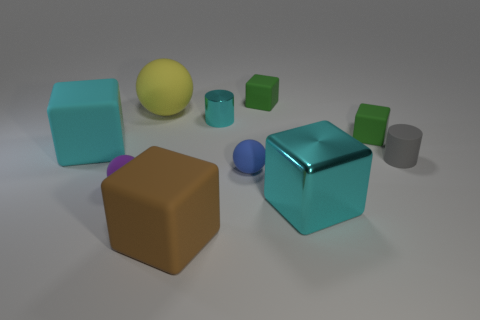How is the lighting affecting the appearance of the objects in the image? The lighting in the image creates a soft ambiance with gentle shadows that help define the shapes and give a sense of depth. Reflections on the metallic surfaces provide visual clues about the texture and material properties, while the matte surfaces absorb light, showing minimal reflections and thus emphasizing their different material characteristics. 